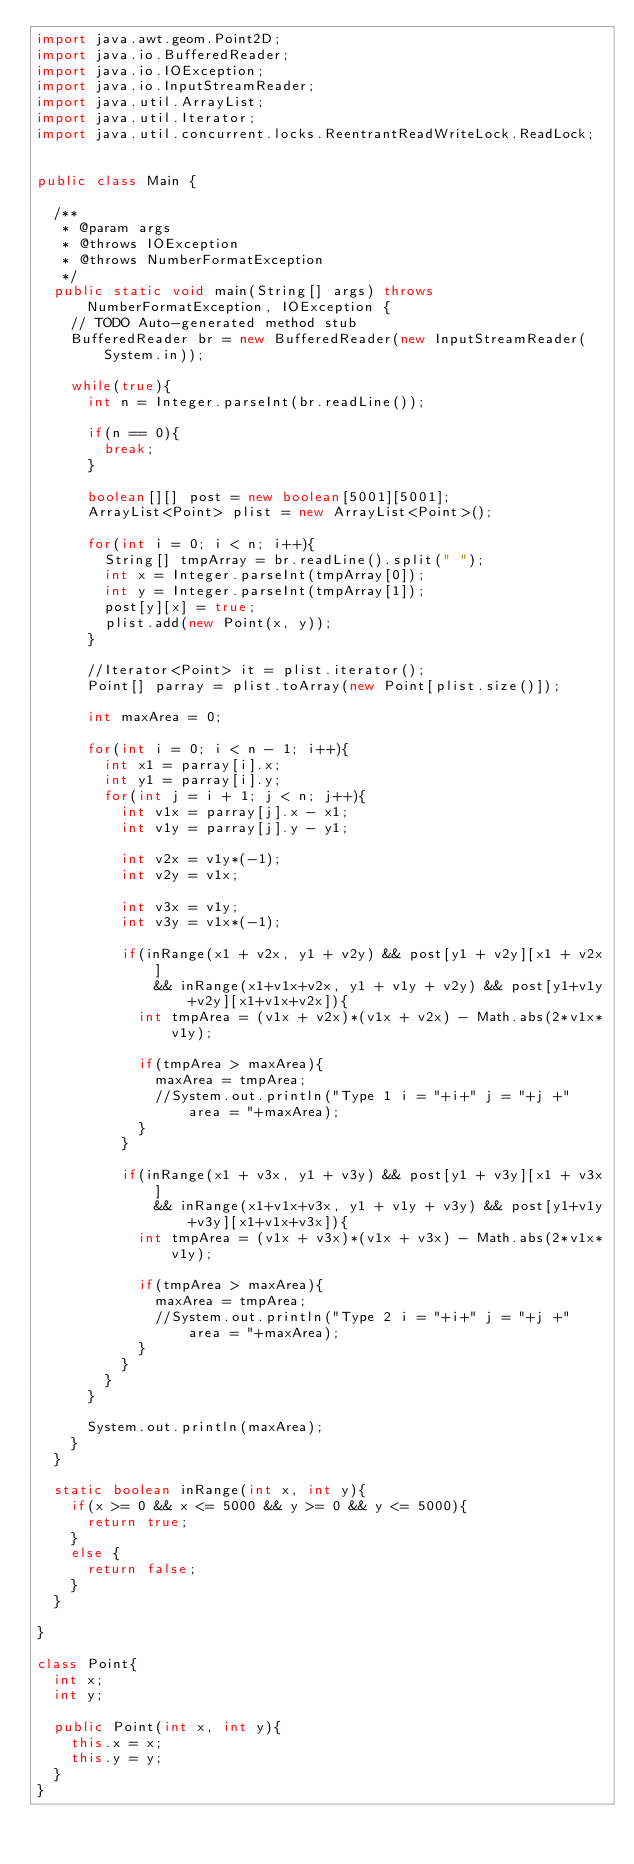<code> <loc_0><loc_0><loc_500><loc_500><_Java_>import java.awt.geom.Point2D;
import java.io.BufferedReader;
import java.io.IOException;
import java.io.InputStreamReader;
import java.util.ArrayList;
import java.util.Iterator;
import java.util.concurrent.locks.ReentrantReadWriteLock.ReadLock;


public class Main {

	/**
	 * @param args
	 * @throws IOException 
	 * @throws NumberFormatException 
	 */
	public static void main(String[] args) throws NumberFormatException, IOException {
		// TODO Auto-generated method stub
		BufferedReader br = new BufferedReader(new InputStreamReader(System.in));
		
		while(true){
			int n = Integer.parseInt(br.readLine());
			
			if(n == 0){
				break;
			}
			
			boolean[][] post = new boolean[5001][5001];
			ArrayList<Point> plist = new ArrayList<Point>();
			
			for(int i = 0; i < n; i++){
				String[] tmpArray = br.readLine().split(" ");
				int x = Integer.parseInt(tmpArray[0]);
				int y = Integer.parseInt(tmpArray[1]);
				post[y][x] = true;
				plist.add(new Point(x, y));
			}
			
			//Iterator<Point> it = plist.iterator();
			Point[] parray = plist.toArray(new Point[plist.size()]);
			
			int maxArea = 0;
			
			for(int i = 0; i < n - 1; i++){
				int x1 = parray[i].x;
				int y1 = parray[i].y;
				for(int j = i + 1; j < n; j++){
					int v1x = parray[j].x - x1;
					int v1y = parray[j].y - y1;
					
					int v2x = v1y*(-1);
					int v2y = v1x;
					
					int v3x = v1y;
					int v3y = v1x*(-1);
					
					if(inRange(x1 + v2x, y1 + v2y) && post[y1 + v2y][x1 + v2x]
							&& inRange(x1+v1x+v2x, y1 + v1y + v2y) && post[y1+v1y+v2y][x1+v1x+v2x]){
						int tmpArea = (v1x + v2x)*(v1x + v2x) - Math.abs(2*v1x*v1y);
						
						if(tmpArea > maxArea){
							maxArea = tmpArea;
							//System.out.println("Type 1 i = "+i+" j = "+j +" area = "+maxArea);
						}
					}
					
					if(inRange(x1 + v3x, y1 + v3y) && post[y1 + v3y][x1 + v3x]
							&& inRange(x1+v1x+v3x, y1 + v1y + v3y) && post[y1+v1y+v3y][x1+v1x+v3x]){
						int tmpArea = (v1x + v3x)*(v1x + v3x) - Math.abs(2*v1x*v1y);
						
						if(tmpArea > maxArea){
							maxArea = tmpArea;
							//System.out.println("Type 2 i = "+i+" j = "+j +" area = "+maxArea);
						}
					}
				}
			}
			
			System.out.println(maxArea);
		}
	}
	
	static boolean inRange(int x, int y){
		if(x >= 0 && x <= 5000 && y >= 0 && y <= 5000){
			return true;
		}
		else {
			return false;
		}
	}

}

class Point{
	int x;
	int y;
	
	public Point(int x, int y){
		this.x = x;
		this.y = y;
	}
}</code> 